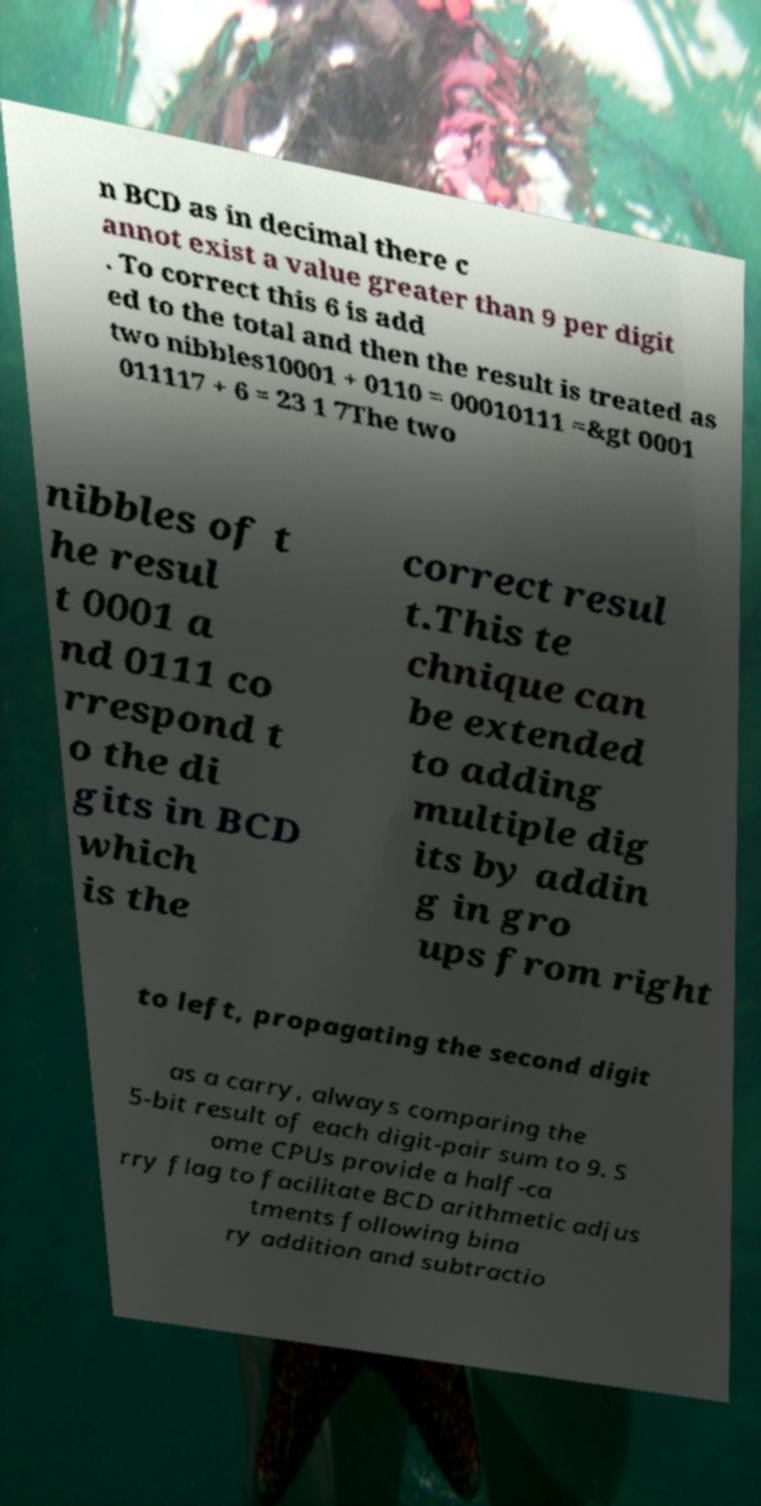For documentation purposes, I need the text within this image transcribed. Could you provide that? n BCD as in decimal there c annot exist a value greater than 9 per digit . To correct this 6 is add ed to the total and then the result is treated as two nibbles10001 + 0110 = 00010111 =&gt 0001 011117 + 6 = 23 1 7The two nibbles of t he resul t 0001 a nd 0111 co rrespond t o the di gits in BCD which is the correct resul t.This te chnique can be extended to adding multiple dig its by addin g in gro ups from right to left, propagating the second digit as a carry, always comparing the 5-bit result of each digit-pair sum to 9. S ome CPUs provide a half-ca rry flag to facilitate BCD arithmetic adjus tments following bina ry addition and subtractio 